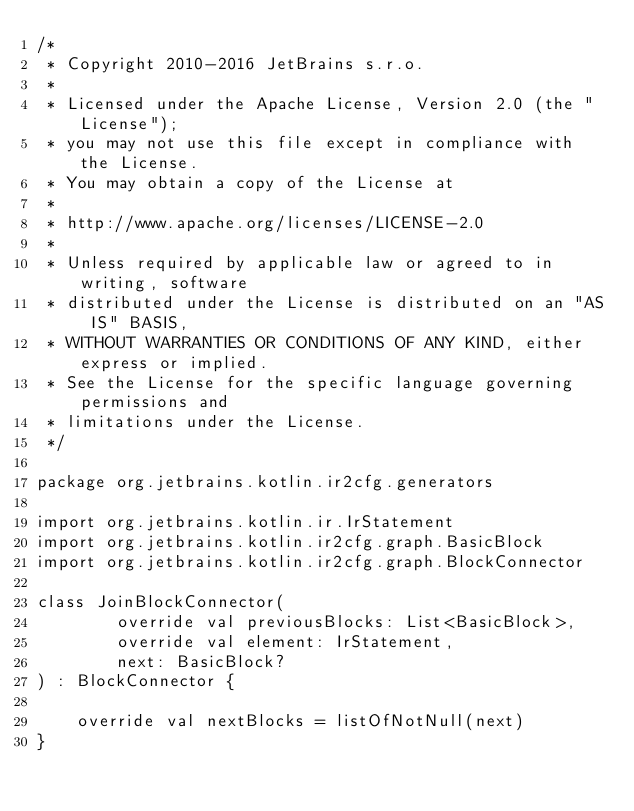Convert code to text. <code><loc_0><loc_0><loc_500><loc_500><_Kotlin_>/*
 * Copyright 2010-2016 JetBrains s.r.o.
 *
 * Licensed under the Apache License, Version 2.0 (the "License");
 * you may not use this file except in compliance with the License.
 * You may obtain a copy of the License at
 *
 * http://www.apache.org/licenses/LICENSE-2.0
 *
 * Unless required by applicable law or agreed to in writing, software
 * distributed under the License is distributed on an "AS IS" BASIS,
 * WITHOUT WARRANTIES OR CONDITIONS OF ANY KIND, either express or implied.
 * See the License for the specific language governing permissions and
 * limitations under the License.
 */

package org.jetbrains.kotlin.ir2cfg.generators

import org.jetbrains.kotlin.ir.IrStatement
import org.jetbrains.kotlin.ir2cfg.graph.BasicBlock
import org.jetbrains.kotlin.ir2cfg.graph.BlockConnector

class JoinBlockConnector(
        override val previousBlocks: List<BasicBlock>,
        override val element: IrStatement,
        next: BasicBlock?
) : BlockConnector {

    override val nextBlocks = listOfNotNull(next)
}</code> 